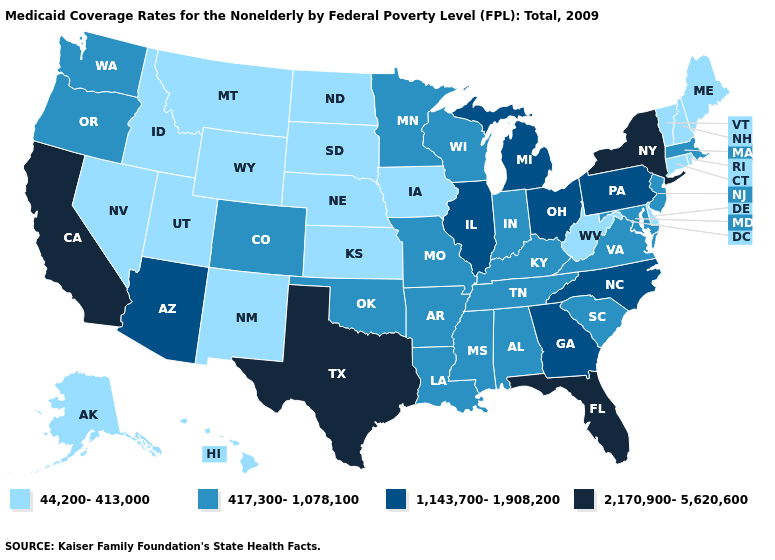Name the states that have a value in the range 2,170,900-5,620,600?
Be succinct. California, Florida, New York, Texas. What is the value of Kentucky?
Write a very short answer. 417,300-1,078,100. Among the states that border Rhode Island , does Massachusetts have the lowest value?
Answer briefly. No. Name the states that have a value in the range 2,170,900-5,620,600?
Keep it brief. California, Florida, New York, Texas. Which states have the lowest value in the West?
Quick response, please. Alaska, Hawaii, Idaho, Montana, Nevada, New Mexico, Utah, Wyoming. What is the highest value in states that border California?
Answer briefly. 1,143,700-1,908,200. Name the states that have a value in the range 1,143,700-1,908,200?
Keep it brief. Arizona, Georgia, Illinois, Michigan, North Carolina, Ohio, Pennsylvania. What is the value of Washington?
Be succinct. 417,300-1,078,100. Which states hav the highest value in the South?
Keep it brief. Florida, Texas. What is the highest value in states that border Texas?
Short answer required. 417,300-1,078,100. Among the states that border Rhode Island , does Massachusetts have the lowest value?
Answer briefly. No. Does South Dakota have a higher value than North Carolina?
Be succinct. No. Name the states that have a value in the range 1,143,700-1,908,200?
Concise answer only. Arizona, Georgia, Illinois, Michigan, North Carolina, Ohio, Pennsylvania. Does South Dakota have the lowest value in the MidWest?
Concise answer only. Yes. Name the states that have a value in the range 44,200-413,000?
Give a very brief answer. Alaska, Connecticut, Delaware, Hawaii, Idaho, Iowa, Kansas, Maine, Montana, Nebraska, Nevada, New Hampshire, New Mexico, North Dakota, Rhode Island, South Dakota, Utah, Vermont, West Virginia, Wyoming. 